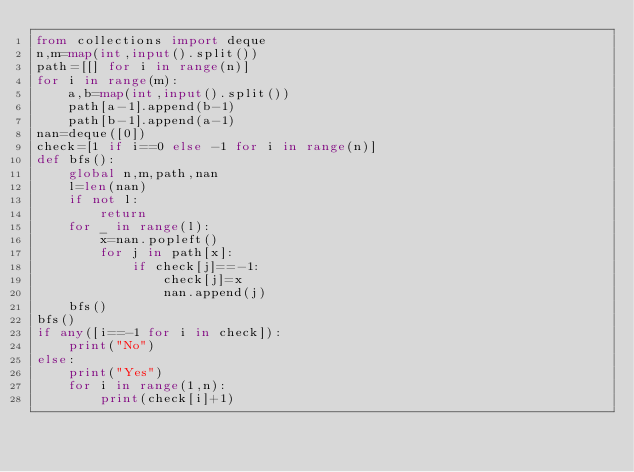Convert code to text. <code><loc_0><loc_0><loc_500><loc_500><_Python_>from collections import deque
n,m=map(int,input().split())
path=[[] for i in range(n)]
for i in range(m):
    a,b=map(int,input().split())
    path[a-1].append(b-1)
    path[b-1].append(a-1)
nan=deque([0])
check=[1 if i==0 else -1 for i in range(n)]
def bfs():
    global n,m,path,nan
    l=len(nan)
    if not l:
        return
    for _ in range(l):
        x=nan.popleft()
        for j in path[x]:
            if check[j]==-1:
                check[j]=x
                nan.append(j)
    bfs()
bfs()
if any([i==-1 for i in check]):
    print("No")
else:
    print("Yes")
    for i in range(1,n):
        print(check[i]+1)</code> 